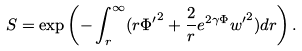Convert formula to latex. <formula><loc_0><loc_0><loc_500><loc_500>S = \exp \left ( - \int _ { r } ^ { \infty } ( r { \Phi ^ { \prime } } ^ { 2 } + \frac { 2 } { r } e ^ { 2 \gamma \Phi } { w ^ { \prime } } ^ { 2 } ) d r \right ) .</formula> 